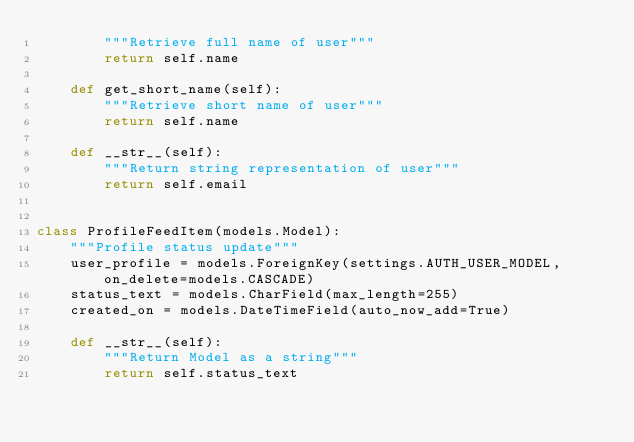Convert code to text. <code><loc_0><loc_0><loc_500><loc_500><_Python_>        """Retrieve full name of user"""
        return self.name

    def get_short_name(self):
        """Retrieve short name of user"""
        return self.name

    def __str__(self):
        """Return string representation of user"""
        return self.email


class ProfileFeedItem(models.Model):
    """Profile status update"""
    user_profile = models.ForeignKey(settings.AUTH_USER_MODEL,on_delete=models.CASCADE)
    status_text = models.CharField(max_length=255)
    created_on = models.DateTimeField(auto_now_add=True)

    def __str__(self):
        """Return Model as a string"""
        return self.status_text
        
</code> 